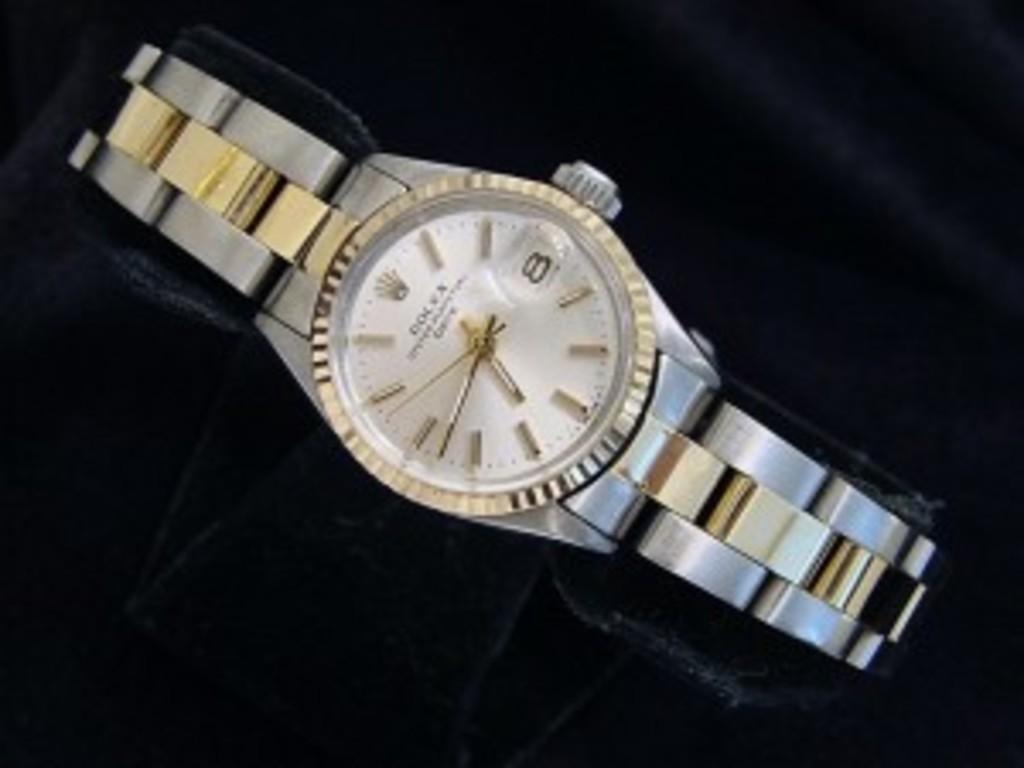Who's the maker of the watch?
Provide a succinct answer. Rolex. What time is it?
Offer a terse response. 6:43. 